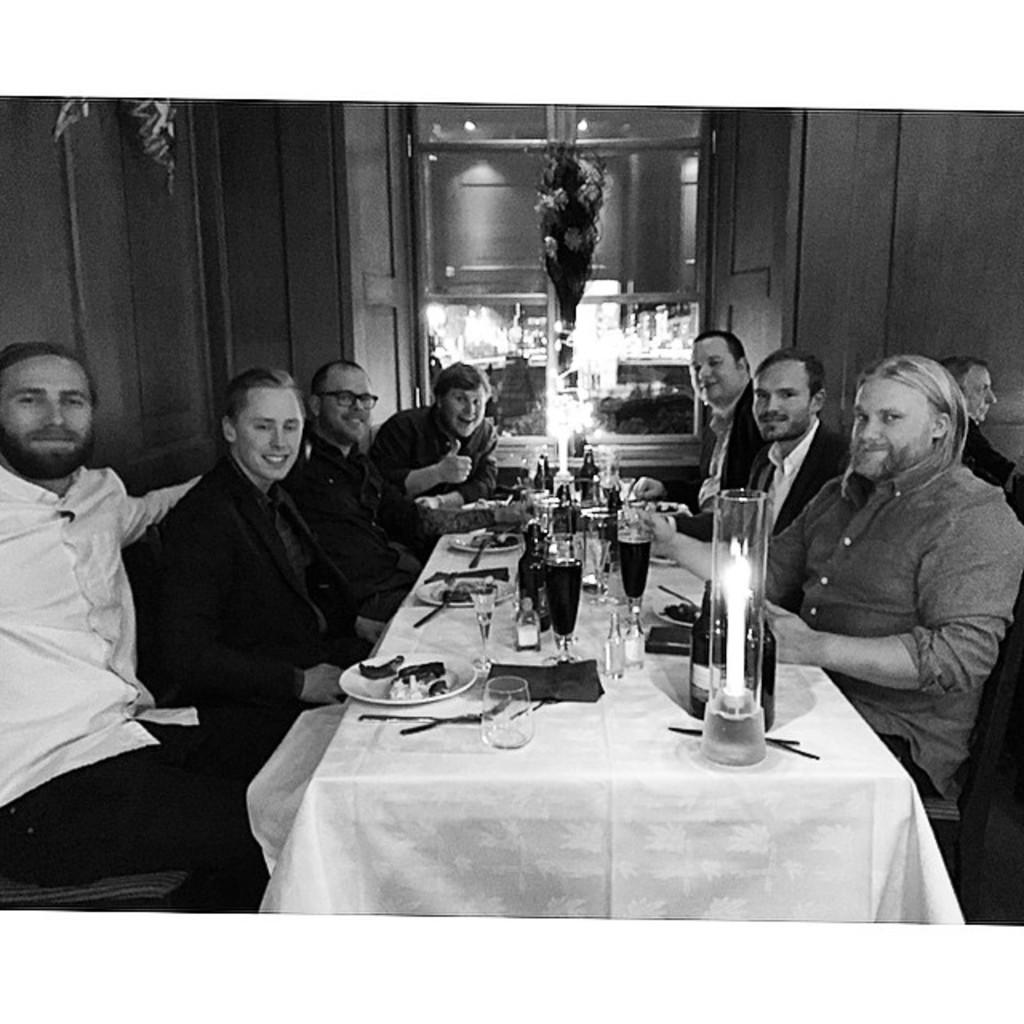How many people are in the image? There is a group of people in the image. What are the people doing in the image? The people are seated on chairs. What items can be seen on the table in the image? There are plates, spoons, wine glasses, and a candle on the table. What type of bun is being used to make a discovery in the image? There is no bun or discovery present in the image. 